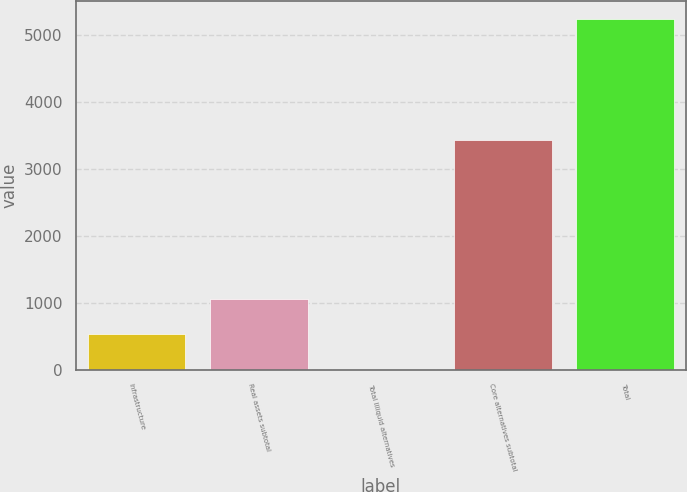<chart> <loc_0><loc_0><loc_500><loc_500><bar_chart><fcel>Infrastructure<fcel>Real assets subtotal<fcel>Total Illiquid alternatives<fcel>Core alternatives subtotal<fcel>Total<nl><fcel>533.2<fcel>1057.4<fcel>9<fcel>3438<fcel>5251<nl></chart> 